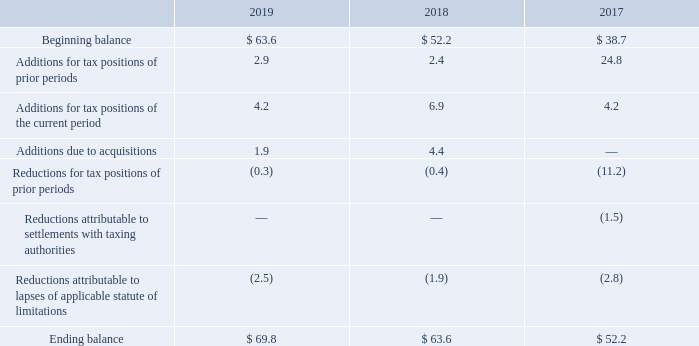The Company recognizes in the Consolidated Financial Statements only those tax positions determined to be “more likely than not” of being sustained upon examination based on the technical merits of the positions. A reconciliation of the beginning and ending amount of unrecognized tax benefits is as follows:
The total amount of unrecognized tax benefits that, if recognized, would impact the effective tax rate is $68.2. Interest and penalties related to unrecognized tax benefits were $1.8 in 2019 and are classified as a component of income tax expense. Accrued interest and penalties were $8.7 at December 31, 2019 and $6.9 at December 31, 2018. During the next twelve months, it is reasonably possible that the unrecognized tax benefits may decrease by a net $6.3, mainly due to anticipated statute of limitations lapses in various jurisdictions.
The Company and its subsidiaries are subject to examinations for U.S. federal income tax as well as income tax in various state, city and foreign jurisdictions. The Company’s federal income tax returns for 2016 through the current period remain open to examination and the relevant state, city and foreign statutes vary. The Company does not expect the assessment of any significant additional tax in excess of amounts reserved.
The Tax Act was signed into U.S. law on December 22, 2017. The Tax Act contains provisions which impact the Company’s income taxes including a reduction in the U.S. federal corporate income tax rate from 35% to 21%, a one-time deemed mandatory repatria- tion tax imposed on all undistributed foreign earnings, and the introduction of a modified territorial taxation system.
The SEC released Staff Accounting Bulletin No. 118 (“SAB 118”) on December 22, 2017 to provide guidance where the accounting under ASC 740, Income Taxes, is incomplete for certain income tax effects of the Tax Act upon issuance of financial statements for the reporting period in which the Tax Act was enacted. SAB 118 provides that if a company could determine a reasonable estimate, that estimate should be reported as a provisional amount and adjusted during a measurement period. If a company is unable to determine a reasonable estimate, no related provisional amounts would be recorded until a reasonable estimate can be determined, within the measurement period. The measurement period extends until all necessary information has been obtained, prepared, and analyzed, but no longer than 12-months from the date of enactment of the Tax Act.
The Company intends to distribute all historical unremitted foreign earnings up to the amount of excess foreign cash, as well as all future foreign earnings that can be repatriated without incremental U.S. federal tax cost. Any remaining outside basis differences relating to the Company’s investments in foreign subsidiaries are no longer expected to be material and will be indefinitely reinvested.
What were the accrued interest and penalties on December 31, 2018, and 2019, respectively? $6.9, $8.7. What were the ending balances of unrecognized tax benefits in fiscal 2017 and 2018, respectively? $ 52.2, $ 63.6. What was the addition for tax positions of prior periods in 2019? 2.9. What is the percentage change in the beginning and ending balance of unrecognized tax benefits in 2019?
Answer scale should be: percent. (69.8-63.6)/63.6 
Answer: 9.75. What is the ratio of total additions to total reductions of unrecognized tax benefits during the fiscal year 2017? (24.8+4.2)/(11.2+1.5+2.8) 
Answer: 1.87. What is the average ending balance of unrecognized tax benefits from 2017 to 2019? (69.8+63.6+52.2)/3 
Answer: 61.87. 